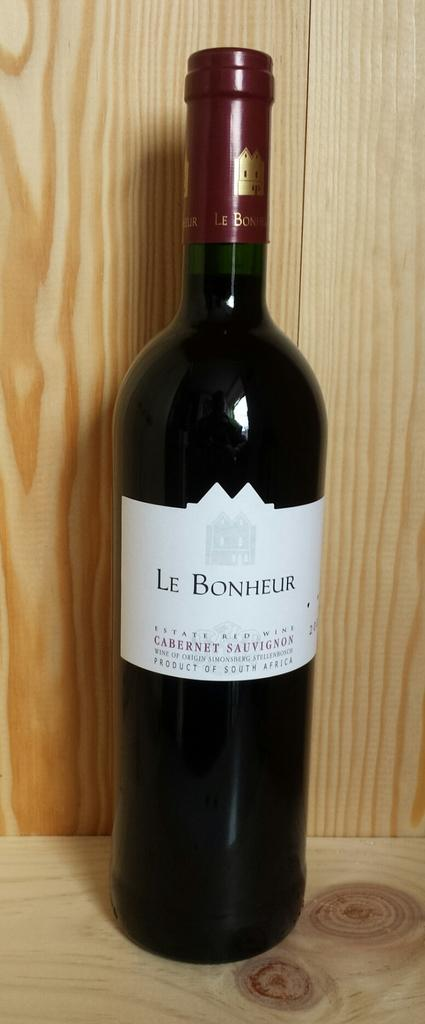<image>
Create a compact narrative representing the image presented. A bottle of Le Bonheur wine is in front of a wooden background. 